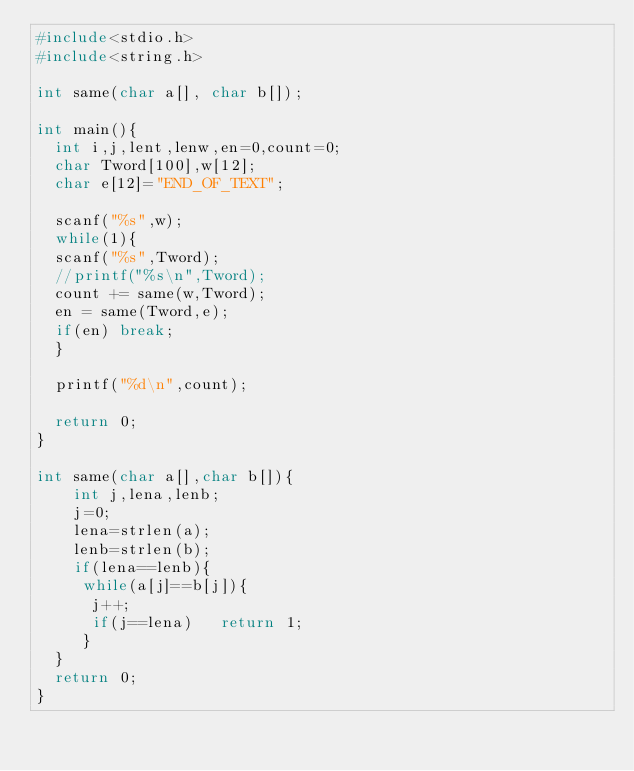Convert code to text. <code><loc_0><loc_0><loc_500><loc_500><_C_>#include<stdio.h>
#include<string.h>

int same(char a[], char b[]);

int main(){
  int i,j,lent,lenw,en=0,count=0;
  char Tword[100],w[12];
  char e[12]="END_OF_TEXT";
  
  scanf("%s",w);
  while(1){
  scanf("%s",Tword);
  //printf("%s\n",Tword);
  count += same(w,Tword);
  en = same(Tword,e);
  if(en) break;
  }

  printf("%d\n",count);
  
  return 0;
}

int same(char a[],char b[]){
	int j,lena,lenb;
	j=0;
	lena=strlen(a);
	lenb=strlen(b);
	if(lena==lenb){
     while(a[j]==b[j]){
      j++;
      if(j==lena)	return 1;
     }
  }
  return 0;
}</code> 